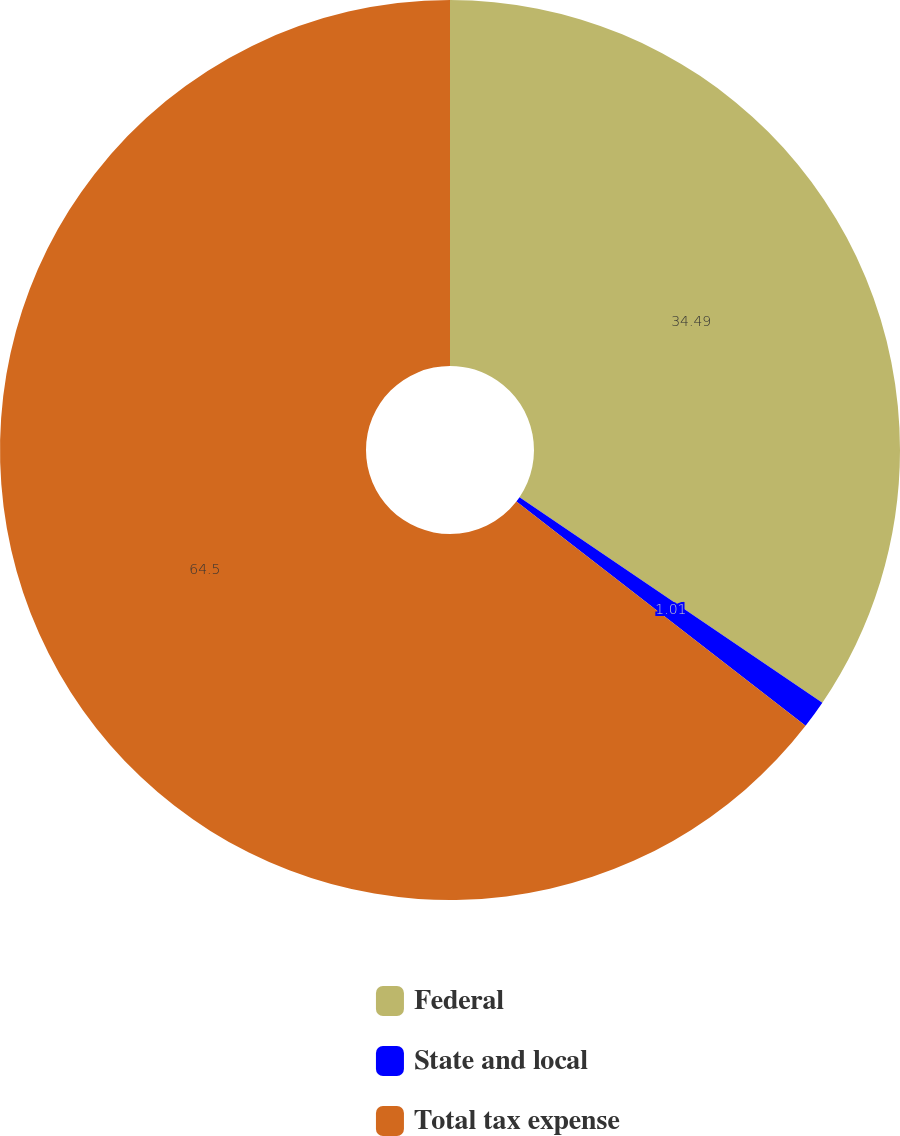Convert chart to OTSL. <chart><loc_0><loc_0><loc_500><loc_500><pie_chart><fcel>Federal<fcel>State and local<fcel>Total tax expense<nl><fcel>34.49%<fcel>1.01%<fcel>64.5%<nl></chart> 